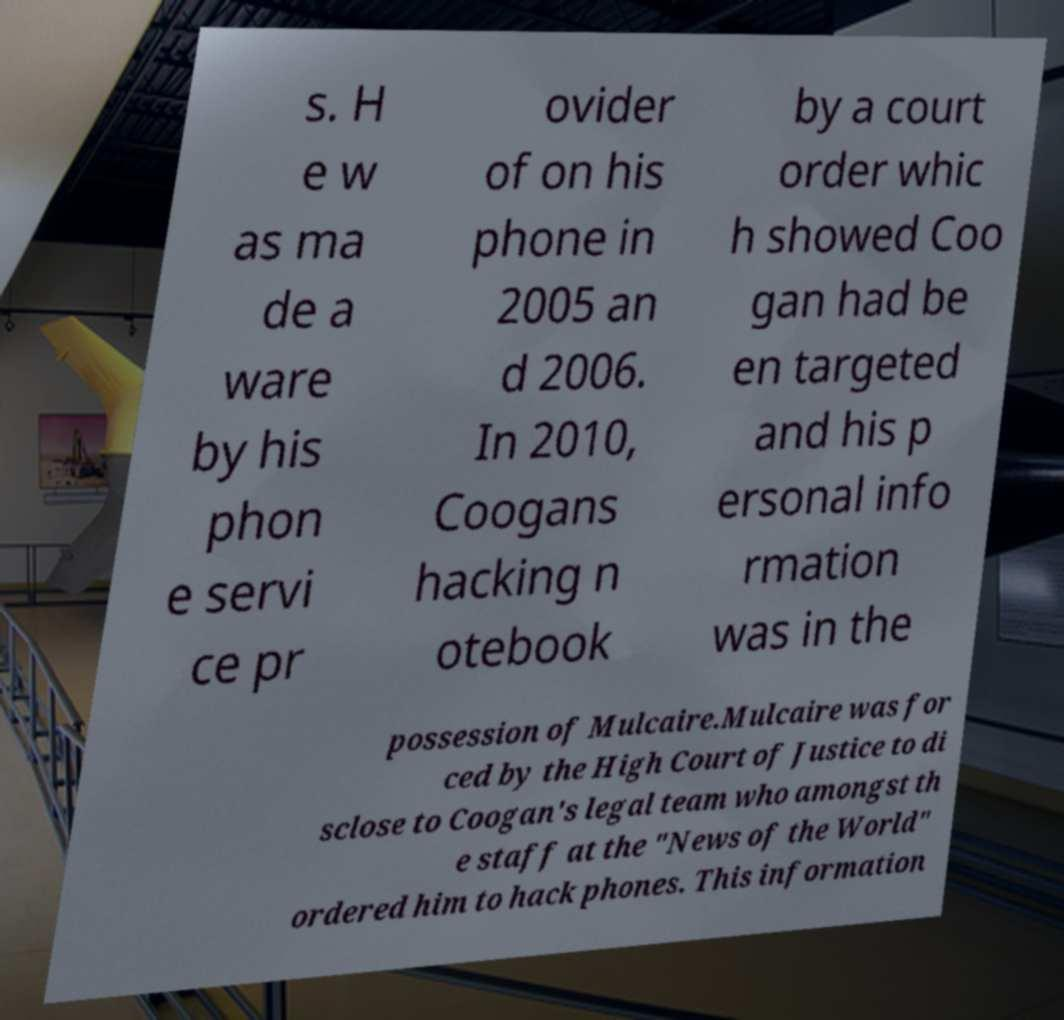I need the written content from this picture converted into text. Can you do that? s. H e w as ma de a ware by his phon e servi ce pr ovider of on his phone in 2005 an d 2006. In 2010, Coogans hacking n otebook by a court order whic h showed Coo gan had be en targeted and his p ersonal info rmation was in the possession of Mulcaire.Mulcaire was for ced by the High Court of Justice to di sclose to Coogan's legal team who amongst th e staff at the "News of the World" ordered him to hack phones. This information 